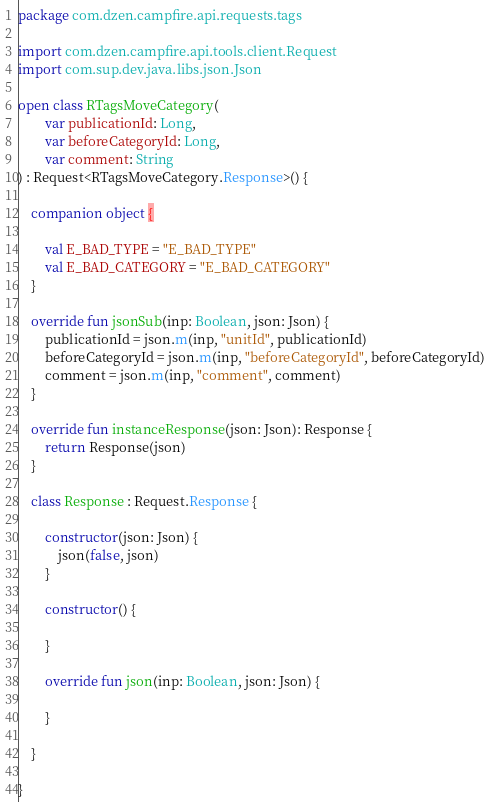Convert code to text. <code><loc_0><loc_0><loc_500><loc_500><_Kotlin_>package com.dzen.campfire.api.requests.tags

import com.dzen.campfire.api.tools.client.Request
import com.sup.dev.java.libs.json.Json

open class RTagsMoveCategory(
        var publicationId: Long,
        var beforeCategoryId: Long,
        var comment: String
) : Request<RTagsMoveCategory.Response>() {

    companion object {

        val E_BAD_TYPE = "E_BAD_TYPE"
        val E_BAD_CATEGORY = "E_BAD_CATEGORY"
    }

    override fun jsonSub(inp: Boolean, json: Json) {
        publicationId = json.m(inp, "unitId", publicationId)
        beforeCategoryId = json.m(inp, "beforeCategoryId", beforeCategoryId)
        comment = json.m(inp, "comment", comment)
    }

    override fun instanceResponse(json: Json): Response {
        return Response(json)
    }

    class Response : Request.Response {

        constructor(json: Json) {
            json(false, json)
        }

        constructor() {

        }

        override fun json(inp: Boolean, json: Json) {

        }

    }

}</code> 